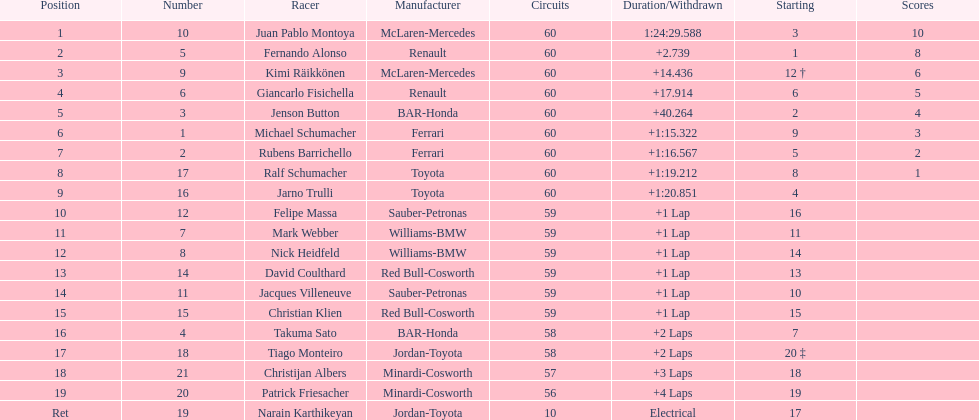Which driver in the top 8, drives a mclaran-mercedes but is not in first place? Kimi Räikkönen. 